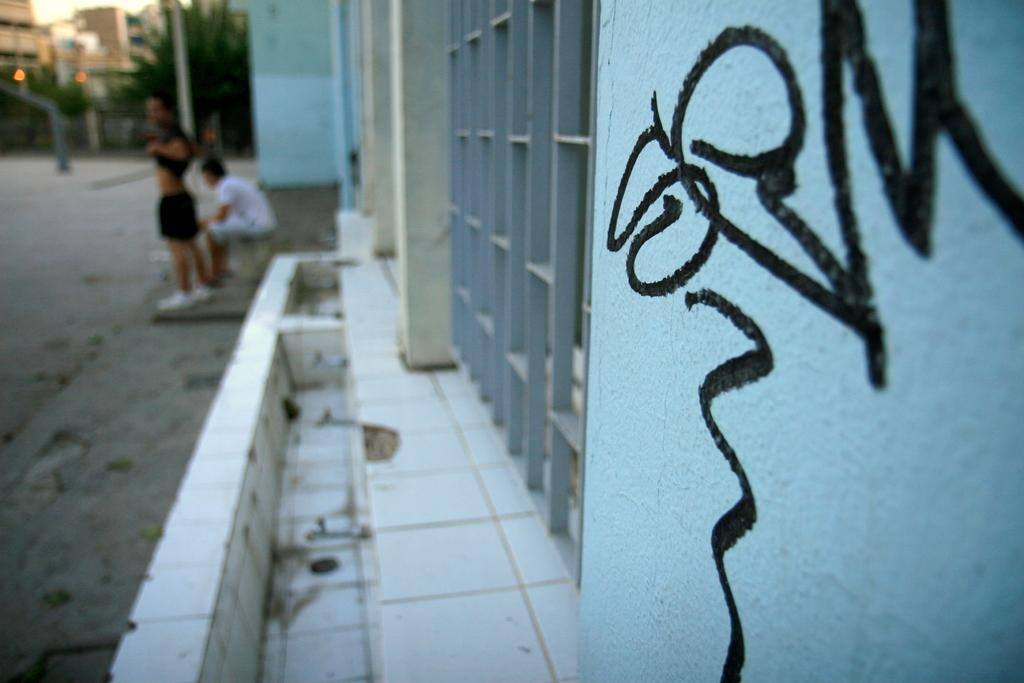What is located in the center of the image? There is a window in the center of the image. What can be seen in the top left side of the image? There are buildings and trees in the top left side of the image. What type of liquid is being discussed in the meeting in the image? There is no meeting or liquid present in the image. What is the quill used for in the image? There is no quill present in the image. 